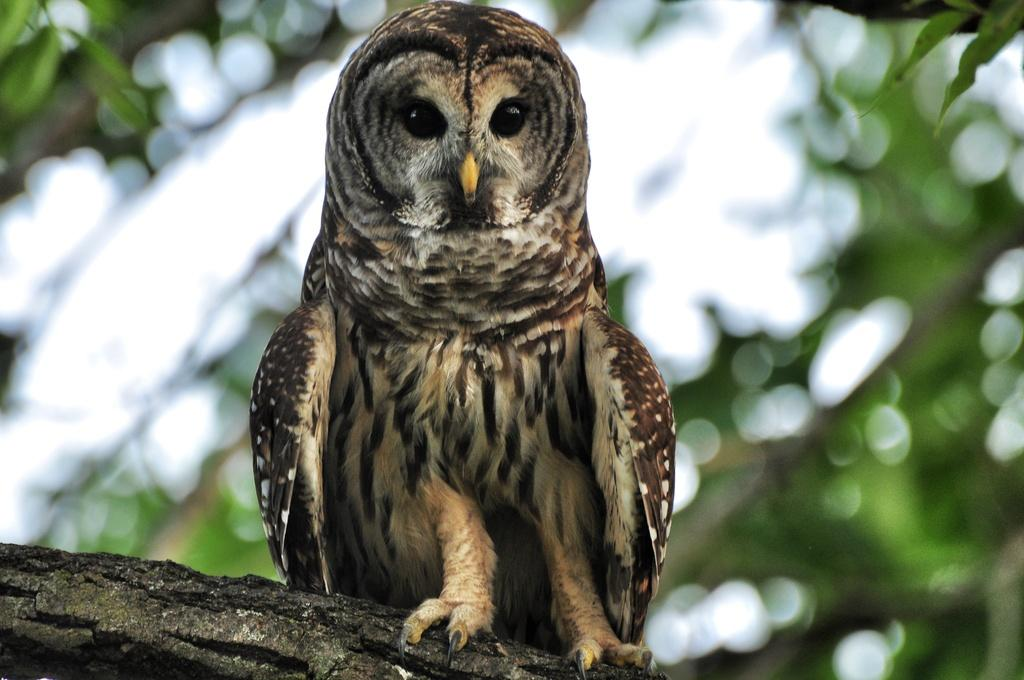What type of animal is in the image? There is an owl in the image. Where is the owl located? The owl is on a tree. What type of holiday is being celebrated in the image? There is no indication of a holiday being celebrated in the image, as it only features an owl on a tree. What type of creature is interacting with the owl in the image? There are no other creatures present in the image, only the owl on the tree. 